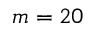Convert formula to latex. <formula><loc_0><loc_0><loc_500><loc_500>m = 2 0</formula> 